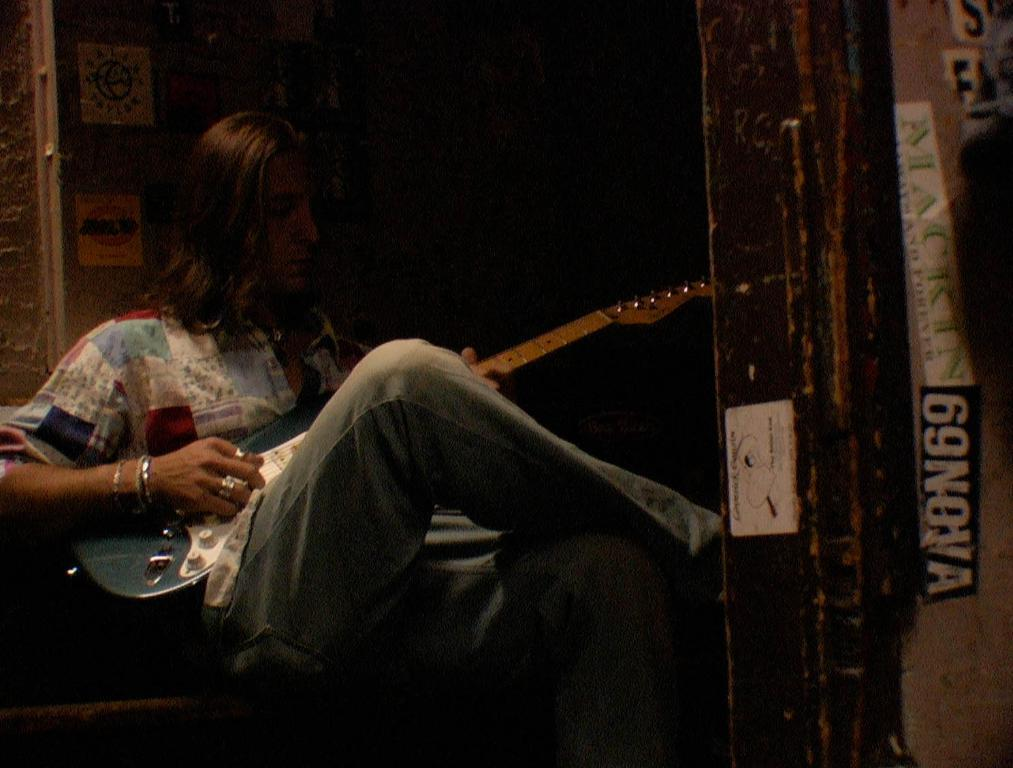<image>
Offer a succinct explanation of the picture presented. a guy playing a guitar in front of a door with 69 Nova on it 